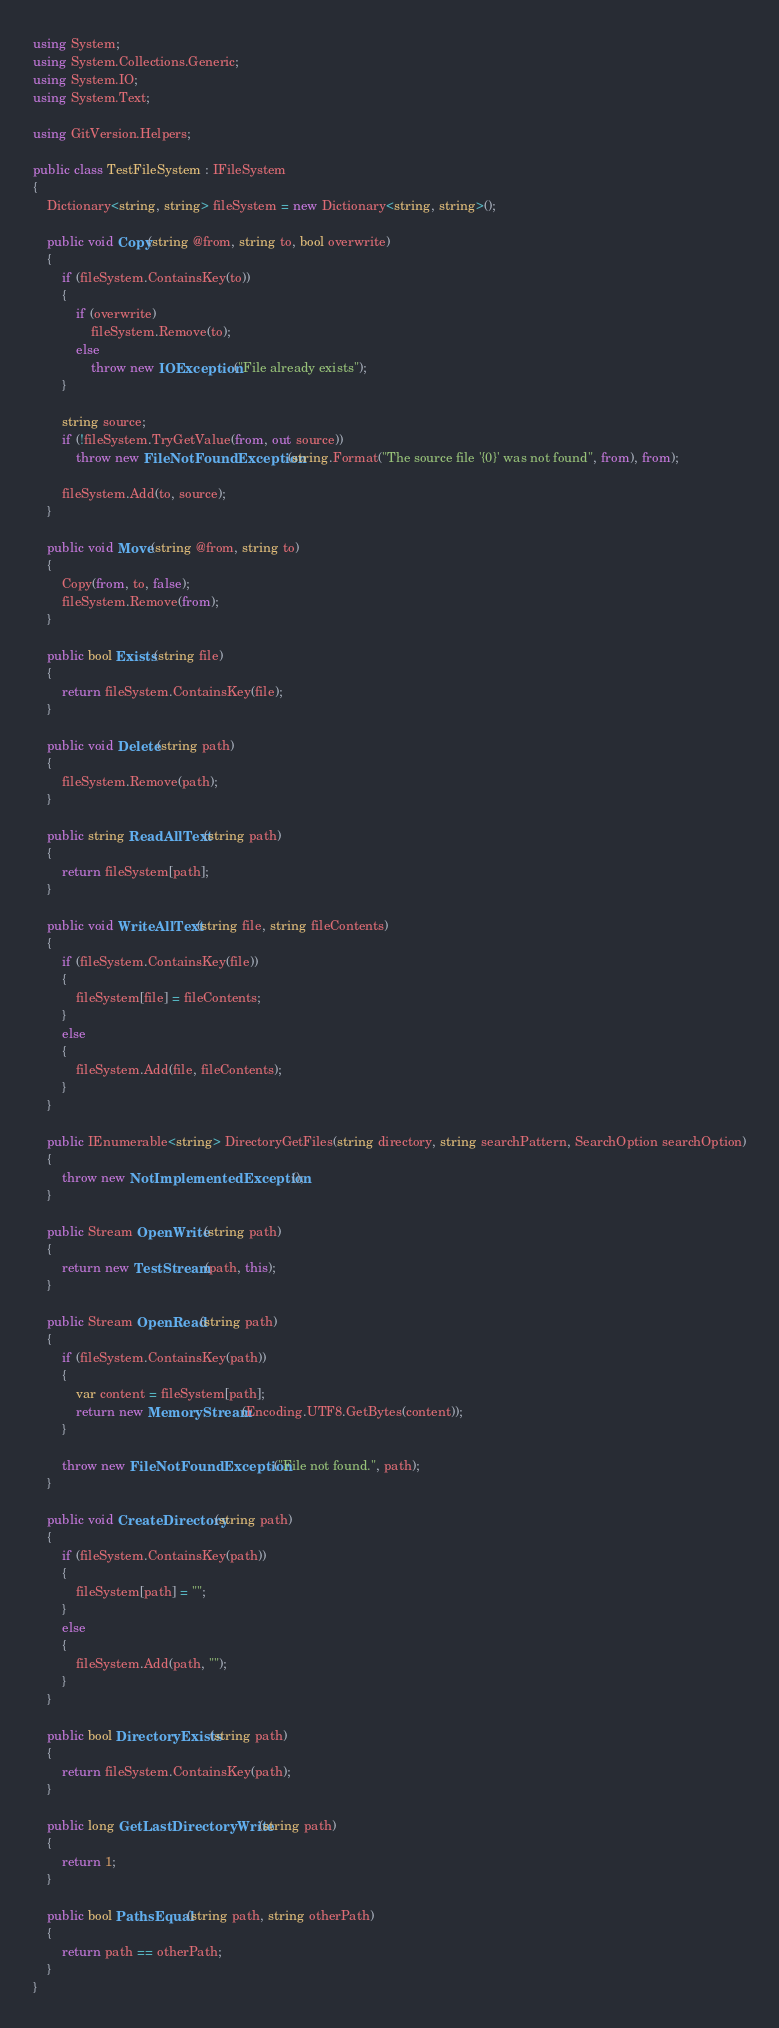Convert code to text. <code><loc_0><loc_0><loc_500><loc_500><_C#_>using System;
using System.Collections.Generic;
using System.IO;
using System.Text;

using GitVersion.Helpers;

public class TestFileSystem : IFileSystem
{
    Dictionary<string, string> fileSystem = new Dictionary<string, string>();

    public void Copy(string @from, string to, bool overwrite)
    {
        if (fileSystem.ContainsKey(to))
        {
            if (overwrite)
                fileSystem.Remove(to);
            else
                throw new IOException("File already exists");
        }

        string source;
        if (!fileSystem.TryGetValue(from, out source))
            throw new FileNotFoundException(string.Format("The source file '{0}' was not found", from), from);

        fileSystem.Add(to, source);
    }

    public void Move(string @from, string to)
    {
        Copy(from, to, false);
        fileSystem.Remove(from);
    }

    public bool Exists(string file)
    {
        return fileSystem.ContainsKey(file);
    }

    public void Delete(string path)
    {
        fileSystem.Remove(path);
    }

    public string ReadAllText(string path)
    {
        return fileSystem[path];
    }

    public void WriteAllText(string file, string fileContents)
    {
        if (fileSystem.ContainsKey(file))
        {
            fileSystem[file] = fileContents;
        }
        else
        {
            fileSystem.Add(file, fileContents);
        }
    }

    public IEnumerable<string> DirectoryGetFiles(string directory, string searchPattern, SearchOption searchOption)
    {
        throw new NotImplementedException();
    }

    public Stream OpenWrite(string path)
    {
        return new TestStream(path, this);
    }

    public Stream OpenRead(string path)
    {
        if (fileSystem.ContainsKey(path))
        {
            var content = fileSystem[path];
            return new MemoryStream(Encoding.UTF8.GetBytes(content));
        }

        throw new FileNotFoundException("File not found.", path);
    }

    public void CreateDirectory(string path)
    {
        if (fileSystem.ContainsKey(path))
        {
            fileSystem[path] = "";
        }
        else
        {
            fileSystem.Add(path, "");
        }
    }

    public bool DirectoryExists(string path)
    {
        return fileSystem.ContainsKey(path);
    }

    public long GetLastDirectoryWrite(string path)
    {
        return 1;
    }

    public bool PathsEqual(string path, string otherPath)
    {
        return path == otherPath;
    }
}</code> 